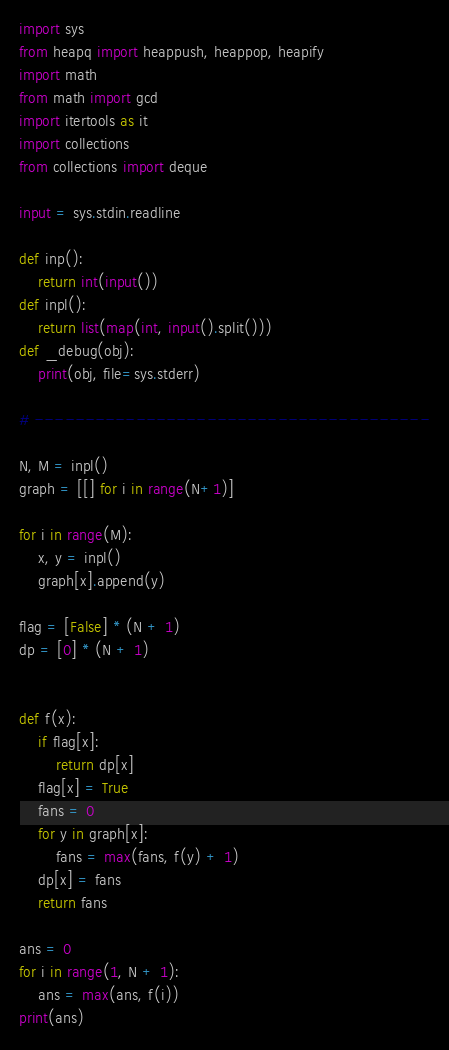<code> <loc_0><loc_0><loc_500><loc_500><_Python_>import sys
from heapq import heappush, heappop, heapify
import math
from math import gcd
import itertools as it
import collections
from collections import deque 

input = sys.stdin.readline

def inp():
    return int(input())
def inpl():
    return list(map(int, input().split()))
def _debug(obj):
    print(obj, file=sys.stderr)

# ---------------------------------------

N, M = inpl()
graph = [[] for i in range(N+1)]

for i in range(M):
    x, y = inpl()
    graph[x].append(y)

flag = [False] * (N + 1)
dp = [0] * (N + 1)


def f(x):
    if flag[x]:
        return dp[x]
    flag[x] = True
    fans = 0
    for y in graph[x]:
        fans = max(fans, f(y) + 1)
    dp[x] = fans
    return fans

ans = 0
for i in range(1, N + 1):
    ans = max(ans, f(i))
print(ans)
</code> 